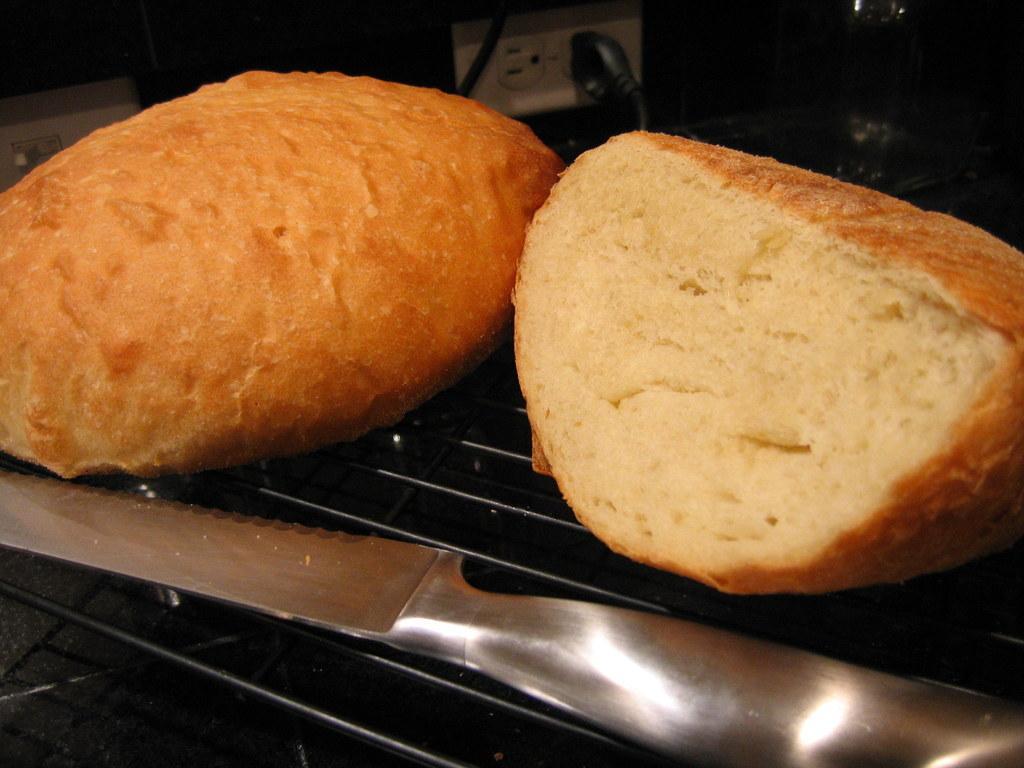Can you describe this image briefly? In the image there are two buns on a grill and beside the buns there is a knife. 